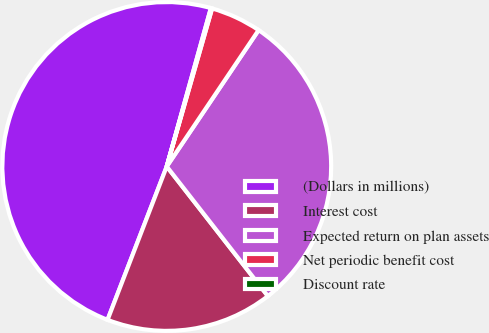Convert chart. <chart><loc_0><loc_0><loc_500><loc_500><pie_chart><fcel>(Dollars in millions)<fcel>Interest cost<fcel>Expected return on plan assets<fcel>Net periodic benefit cost<fcel>Discount rate<nl><fcel>48.47%<fcel>16.41%<fcel>30.02%<fcel>4.99%<fcel>0.12%<nl></chart> 